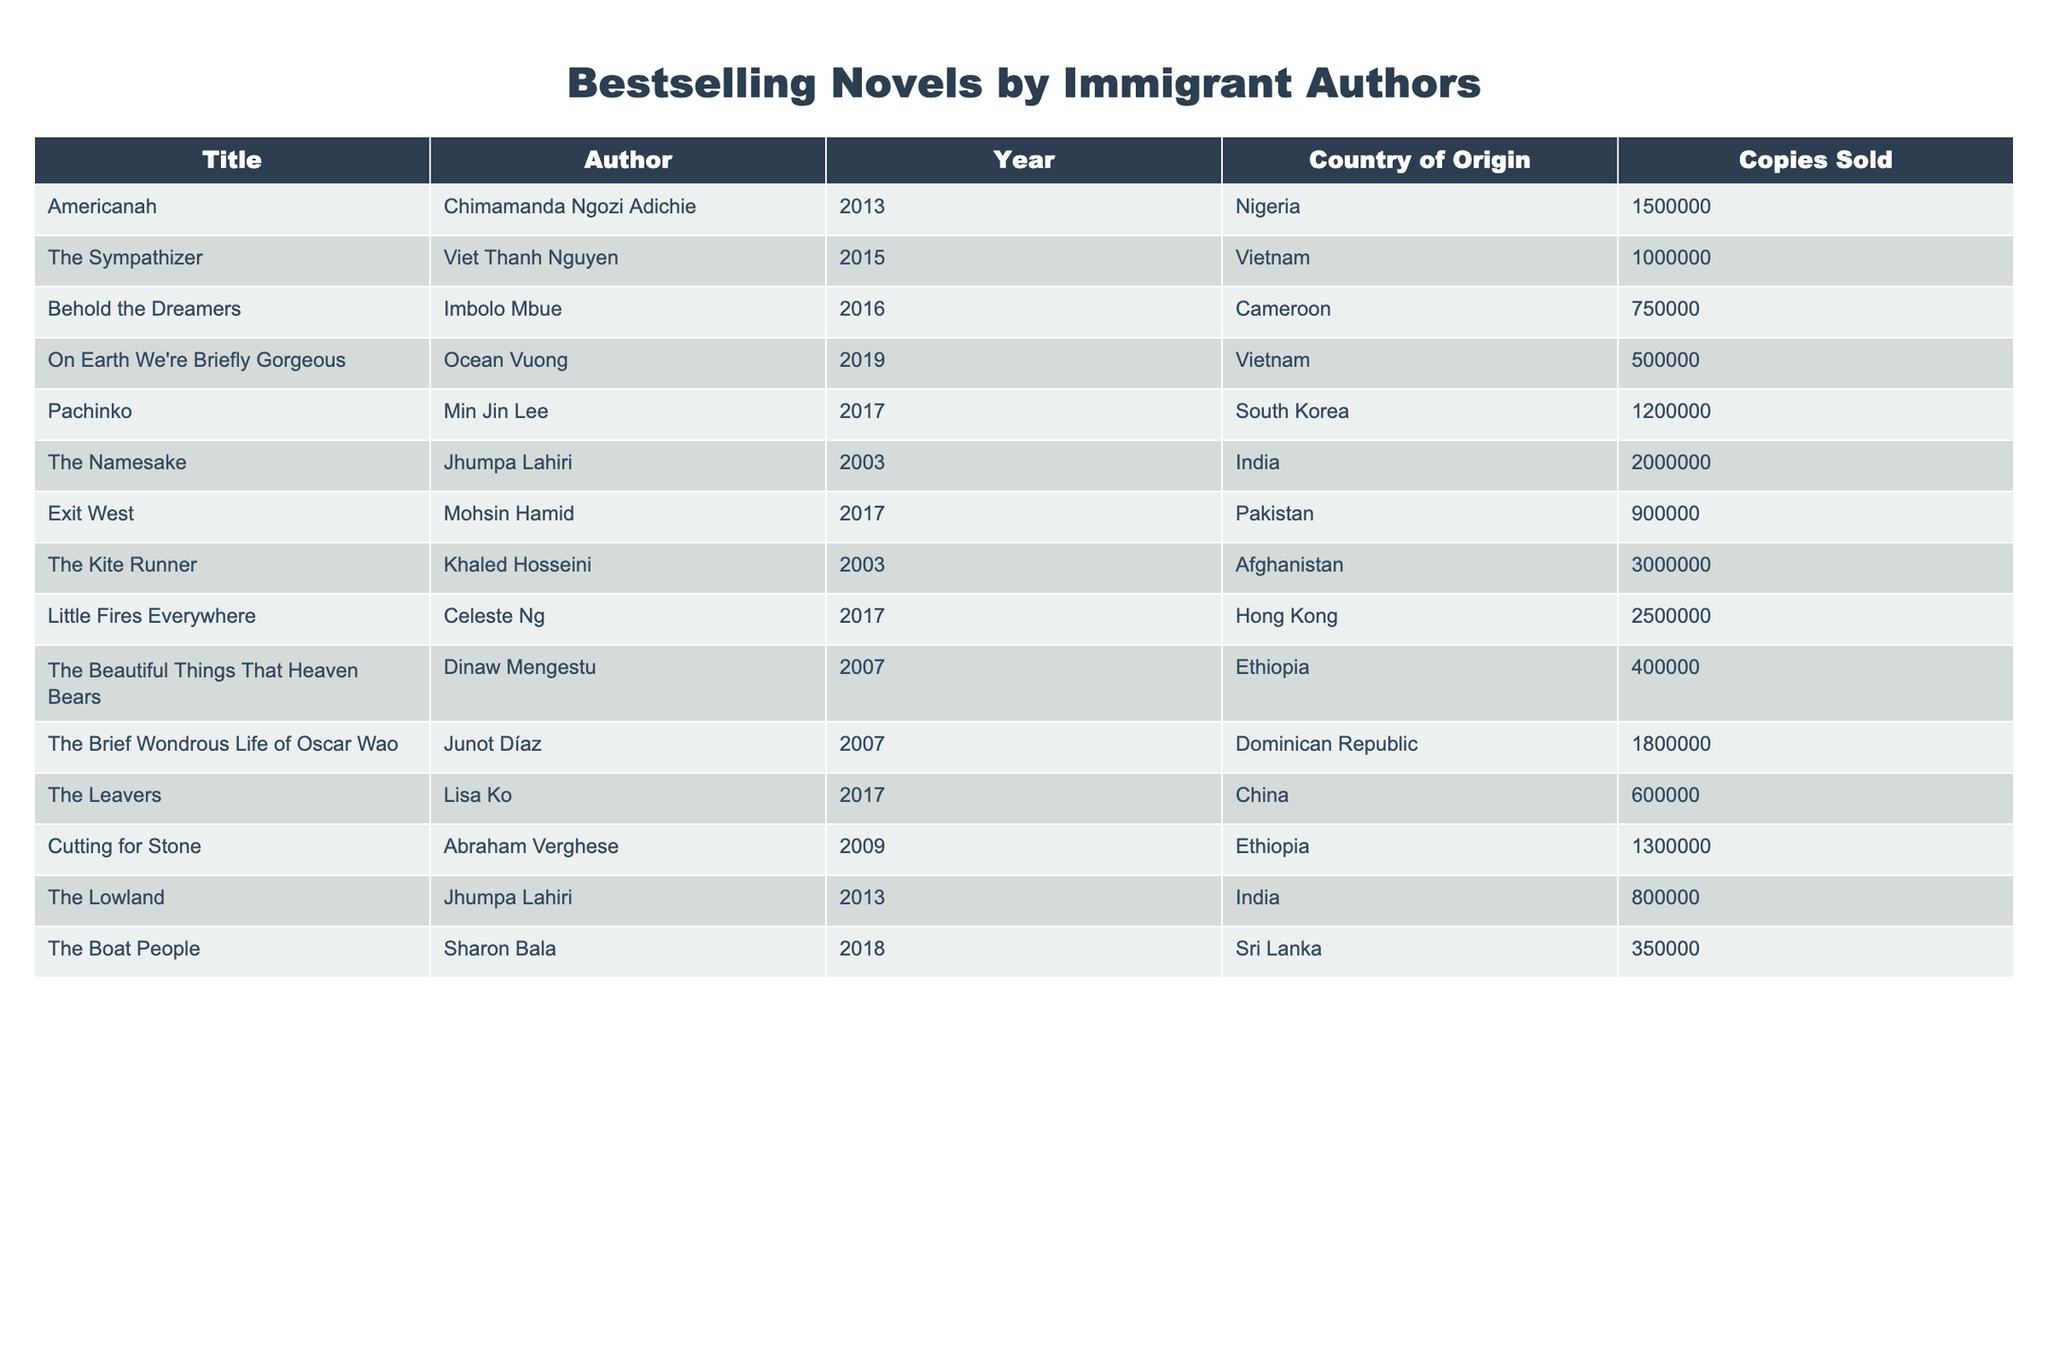What is the title of the bestselling novel by an immigrant author from Nigeria? The table lists "Americanah" by Chimamanda Ngozi Adichie as the bestselling novel from Nigeria, with 1,500,000 copies sold.
Answer: Americanah Which author has written the most copies sold according to the table? "The Kite Runner" by Khaled Hosseini has the highest sales, totaling 3,000,000 copies.
Answer: Khaled Hosseini How many copies did "The Sympathizer" sell? The table shows that "The Sympathizer" by Viet Thanh Nguyen sold 1,000,000 copies.
Answer: 1,000,000 What is the total number of copies sold for novels by authors from Vietnam? The total for Vietnamese authors, "The Sympathizer" and "On Earth We're Briefly Gorgeous," is 1,000,000 + 500,000 = 1,500,000.
Answer: 1,500,000 Did "Little Fires Everywhere" sell more copies than "Behold the Dreamers"? Yes, "Little Fires Everywhere" sold 2,500,000 copies, while "Behold the Dreamers" sold 750,000 copies.
Answer: Yes What is the median number of copies sold among the novels listed? First, organize the sales figures: 400,000, 500,000, 600,000, 750,000, 800,000, 900,000, 1,000,000, 1,200,000, 1,300,000, 1,500,000, 1,800,000, 2,000,000, 2,500,000, 3,000,000. There are 14 entries; the median is the average of the 7th and 8th values: (1,000,000 + 1,200,000) / 2 = 1,100,000.
Answer: 1,100,000 Which country of origin has the highest total sales represented in the table? Calculating totals for each country: Nigeria (1,500,000), Vietnam (1,500,000), Cameroon (750,000), South Korea (1,200,000), India (2,800,000), Afghanistan (3,000,000), and others. The highest total is from Afghanistan with 3,000,000.
Answer: Afghanistan Is there a novel by a Chinese author on the list? Yes, "The Leavers" by Lisa Ko is included, representing a Chinese author.
Answer: Yes What is the total sales for all novels by authors from India? The total sales for Indian authors "The Namesake" (2,000,000) and "The Lowland" (800,000) is 2,000,000 + 800,000 = 2,800,000.
Answer: 2,800,000 